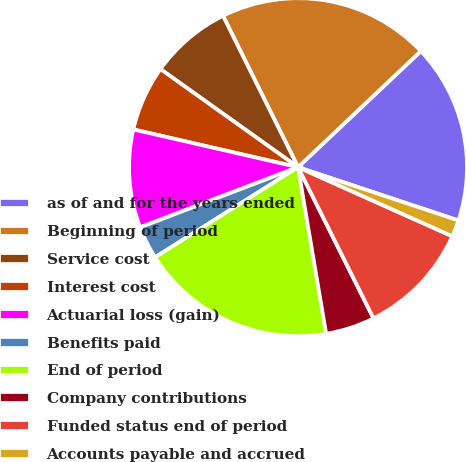Convert chart to OTSL. <chart><loc_0><loc_0><loc_500><loc_500><pie_chart><fcel>as of and for the years ended<fcel>Beginning of period<fcel>Service cost<fcel>Interest cost<fcel>Actuarial loss (gain)<fcel>Benefits paid<fcel>End of period<fcel>Company contributions<fcel>Funded status end of period<fcel>Accounts payable and accrued<nl><fcel>17.16%<fcel>20.27%<fcel>7.82%<fcel>6.27%<fcel>9.38%<fcel>3.16%<fcel>18.71%<fcel>4.71%<fcel>10.93%<fcel>1.6%<nl></chart> 